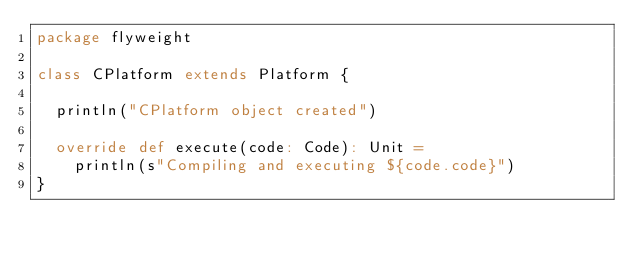Convert code to text. <code><loc_0><loc_0><loc_500><loc_500><_Scala_>package flyweight

class CPlatform extends Platform {

  println("CPlatform object created")

  override def execute(code: Code): Unit =
    println(s"Compiling and executing ${code.code}")
}
</code> 